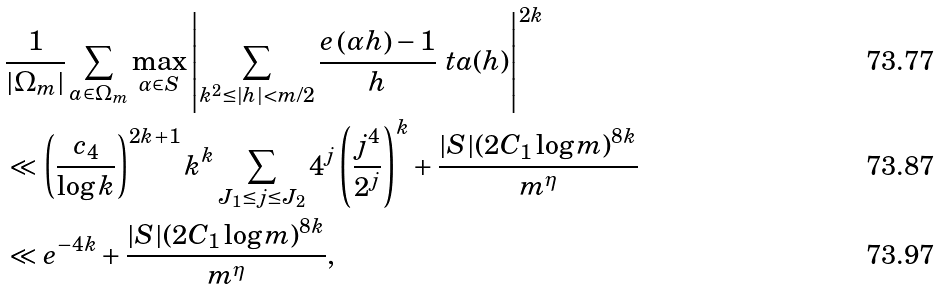Convert formula to latex. <formula><loc_0><loc_0><loc_500><loc_500>& \frac { 1 } { | \Omega _ { m } | } \sum _ { a \in \Omega _ { m } } \max _ { \alpha \in S } \left | \sum _ { k ^ { 2 } \leq | h | < m / 2 } \frac { e \left ( \alpha h \right ) - 1 } { h } \ t a ( h ) \right | ^ { 2 k } \\ & \ll \left ( \frac { c _ { 4 } } { \log k } \right ) ^ { 2 k + 1 } k ^ { k } \sum _ { J _ { 1 } \leq j \leq J _ { 2 } } 4 ^ { j } \left ( \frac { j ^ { 4 } } { 2 ^ { j } } \right ) ^ { k } + \frac { | S | ( 2 C _ { 1 } \log m ) ^ { 8 k } } { m ^ { \eta } } \\ & \ll e ^ { - 4 k } + \frac { | S | ( 2 C _ { 1 } \log m ) ^ { 8 k } } { m ^ { \eta } } ,</formula> 